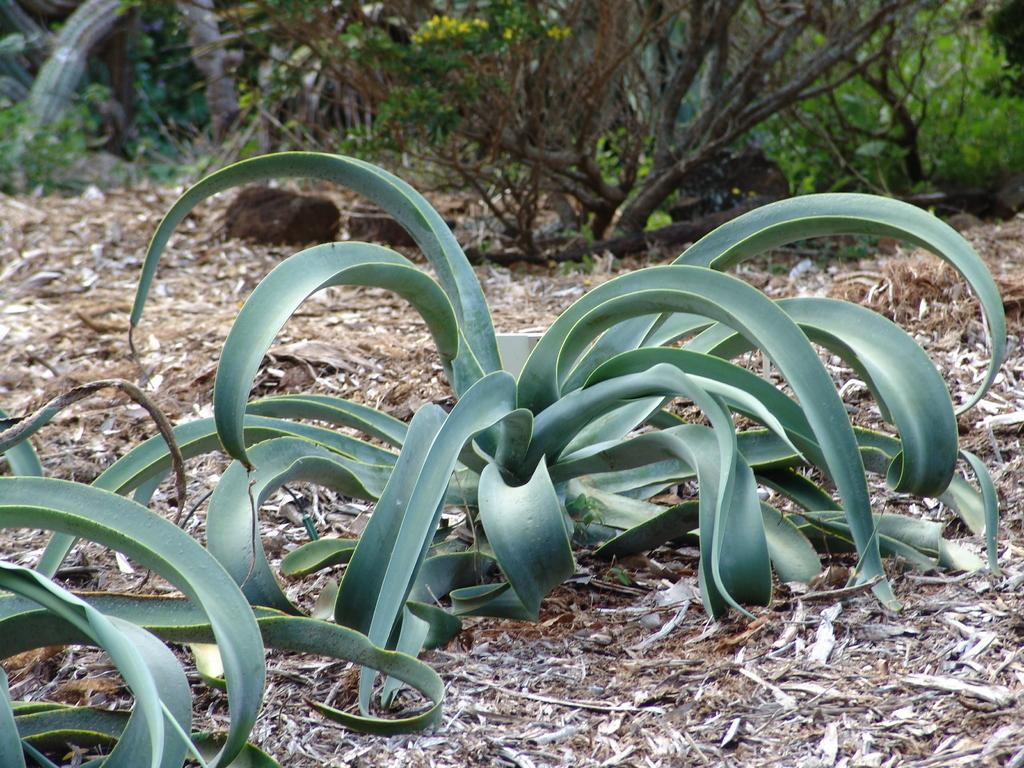What type of living organisms are present in the image? The image contains plants. What can be found on the ground in the image? There are dried leaves on the ground. What is visible in the background of the image? There are trees and rocks in the background of the image. How many jellyfish can be seen swimming in the image? There are no jellyfish present in the image; it features plants, dried leaves, trees, and rocks. 